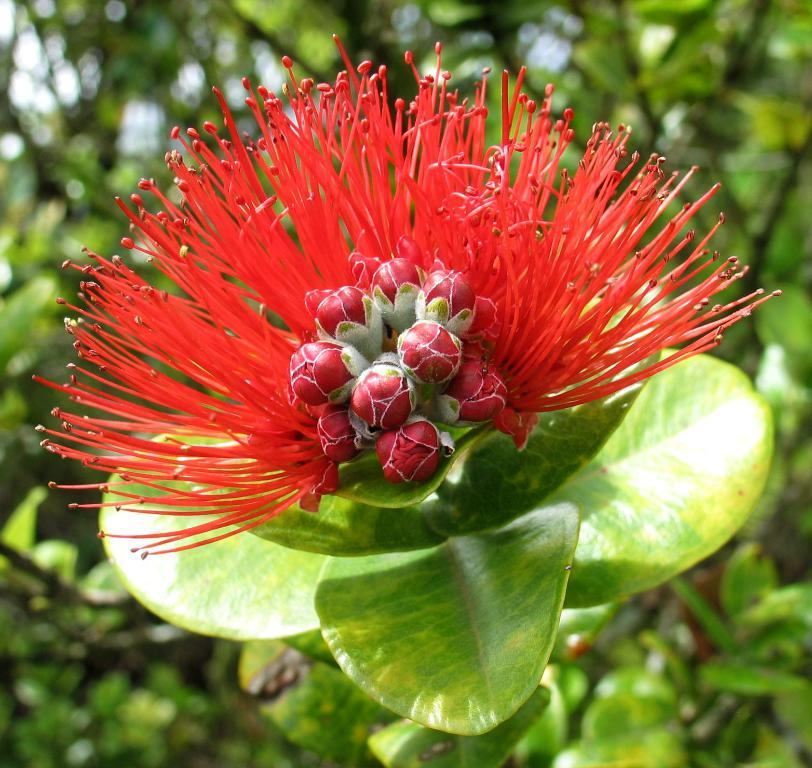What is present in the image? There is a plant in the image. What can be observed about the plant's flower? The plant has a red flower. What type of pipe is being used to water the plant in the image? There is no pipe present in the image, and the plant does not appear to be watered. 